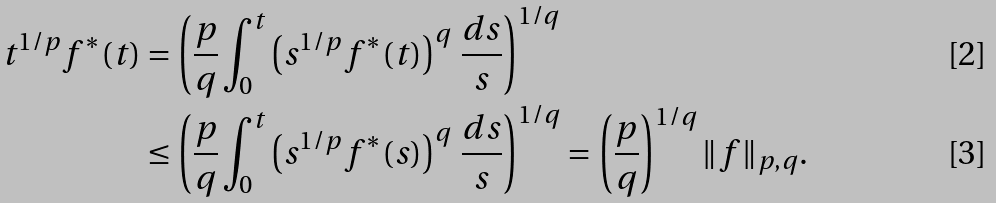<formula> <loc_0><loc_0><loc_500><loc_500>t ^ { 1 / p } f ^ { * } ( t ) & = \left ( \frac { p } { q } \int _ { 0 } ^ { t } \left ( s ^ { 1 / p } f ^ { * } ( t ) \right ) ^ { q } \, \frac { d s } { s } \right ) ^ { 1 / q } \\ & \leq \left ( \frac { p } { q } \int _ { 0 } ^ { t } \left ( s ^ { 1 / p } f ^ { * } ( s ) \right ) ^ { q } \, \frac { d s } { s } \right ) ^ { 1 / q } = \left ( \frac { p } { q } \right ) ^ { 1 / q } \| f \| _ { p , q } .</formula> 